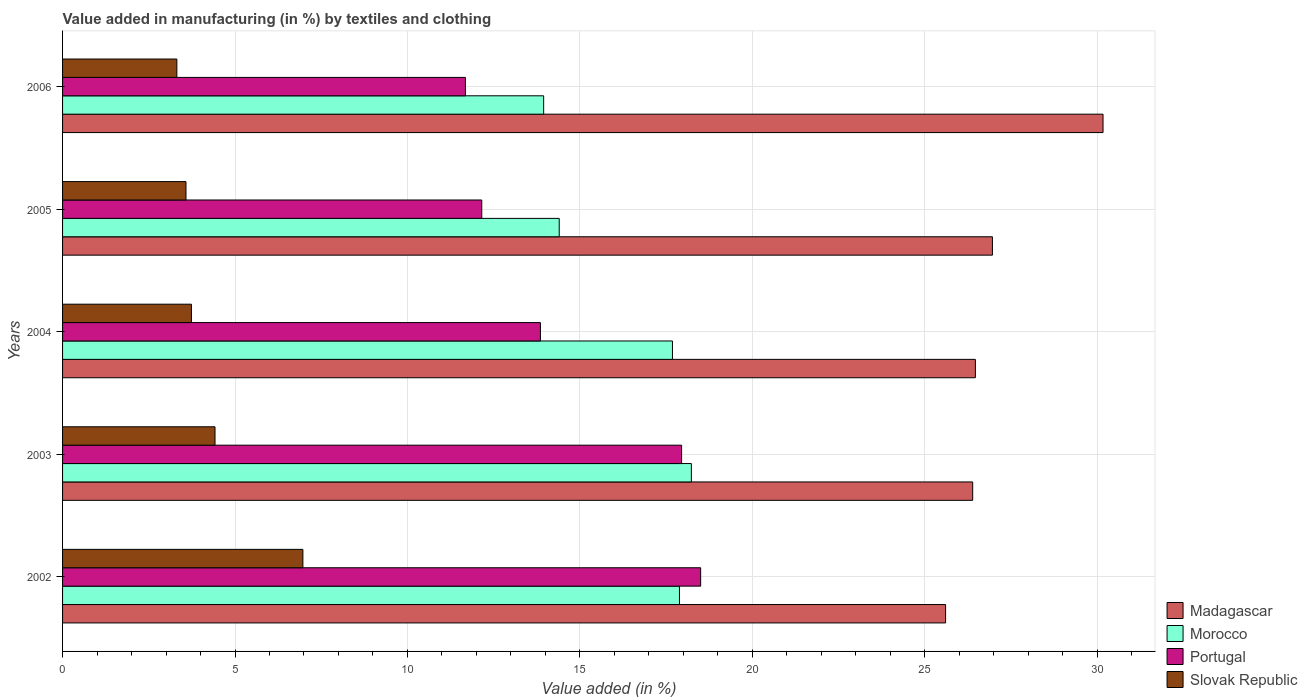How many groups of bars are there?
Provide a short and direct response. 5. Are the number of bars on each tick of the Y-axis equal?
Keep it short and to the point. Yes. How many bars are there on the 3rd tick from the top?
Your response must be concise. 4. How many bars are there on the 5th tick from the bottom?
Offer a terse response. 4. What is the label of the 2nd group of bars from the top?
Provide a short and direct response. 2005. What is the percentage of value added in manufacturing by textiles and clothing in Slovak Republic in 2003?
Make the answer very short. 4.42. Across all years, what is the maximum percentage of value added in manufacturing by textiles and clothing in Morocco?
Your answer should be very brief. 18.23. Across all years, what is the minimum percentage of value added in manufacturing by textiles and clothing in Slovak Republic?
Give a very brief answer. 3.31. In which year was the percentage of value added in manufacturing by textiles and clothing in Madagascar minimum?
Ensure brevity in your answer.  2002. What is the total percentage of value added in manufacturing by textiles and clothing in Portugal in the graph?
Offer a very short reply. 74.15. What is the difference between the percentage of value added in manufacturing by textiles and clothing in Slovak Republic in 2004 and that in 2006?
Offer a very short reply. 0.42. What is the difference between the percentage of value added in manufacturing by textiles and clothing in Morocco in 2006 and the percentage of value added in manufacturing by textiles and clothing in Portugal in 2002?
Make the answer very short. -4.55. What is the average percentage of value added in manufacturing by textiles and clothing in Slovak Republic per year?
Provide a short and direct response. 4.4. In the year 2004, what is the difference between the percentage of value added in manufacturing by textiles and clothing in Madagascar and percentage of value added in manufacturing by textiles and clothing in Morocco?
Keep it short and to the point. 8.78. What is the ratio of the percentage of value added in manufacturing by textiles and clothing in Portugal in 2004 to that in 2005?
Keep it short and to the point. 1.14. Is the difference between the percentage of value added in manufacturing by textiles and clothing in Madagascar in 2003 and 2006 greater than the difference between the percentage of value added in manufacturing by textiles and clothing in Morocco in 2003 and 2006?
Your answer should be very brief. No. What is the difference between the highest and the second highest percentage of value added in manufacturing by textiles and clothing in Portugal?
Your answer should be very brief. 0.55. What is the difference between the highest and the lowest percentage of value added in manufacturing by textiles and clothing in Morocco?
Make the answer very short. 4.28. In how many years, is the percentage of value added in manufacturing by textiles and clothing in Slovak Republic greater than the average percentage of value added in manufacturing by textiles and clothing in Slovak Republic taken over all years?
Your response must be concise. 2. What does the 1st bar from the top in 2005 represents?
Offer a terse response. Slovak Republic. What does the 3rd bar from the bottom in 2004 represents?
Your answer should be compact. Portugal. Are all the bars in the graph horizontal?
Your answer should be very brief. Yes. How many years are there in the graph?
Offer a terse response. 5. Are the values on the major ticks of X-axis written in scientific E-notation?
Provide a short and direct response. No. Does the graph contain any zero values?
Offer a terse response. No. Does the graph contain grids?
Ensure brevity in your answer.  Yes. Where does the legend appear in the graph?
Keep it short and to the point. Bottom right. How many legend labels are there?
Your answer should be compact. 4. What is the title of the graph?
Your answer should be very brief. Value added in manufacturing (in %) by textiles and clothing. What is the label or title of the X-axis?
Provide a short and direct response. Value added (in %). What is the Value added (in %) of Madagascar in 2002?
Keep it short and to the point. 25.61. What is the Value added (in %) of Morocco in 2002?
Provide a succinct answer. 17.89. What is the Value added (in %) of Portugal in 2002?
Make the answer very short. 18.5. What is the Value added (in %) in Slovak Republic in 2002?
Make the answer very short. 6.97. What is the Value added (in %) in Madagascar in 2003?
Offer a terse response. 26.39. What is the Value added (in %) in Morocco in 2003?
Your answer should be compact. 18.23. What is the Value added (in %) in Portugal in 2003?
Offer a very short reply. 17.95. What is the Value added (in %) of Slovak Republic in 2003?
Provide a short and direct response. 4.42. What is the Value added (in %) of Madagascar in 2004?
Keep it short and to the point. 26.47. What is the Value added (in %) in Morocco in 2004?
Offer a very short reply. 17.68. What is the Value added (in %) in Portugal in 2004?
Keep it short and to the point. 13.86. What is the Value added (in %) of Slovak Republic in 2004?
Your answer should be very brief. 3.74. What is the Value added (in %) in Madagascar in 2005?
Offer a very short reply. 26.96. What is the Value added (in %) of Morocco in 2005?
Make the answer very short. 14.4. What is the Value added (in %) in Portugal in 2005?
Give a very brief answer. 12.16. What is the Value added (in %) of Slovak Republic in 2005?
Provide a short and direct response. 3.58. What is the Value added (in %) of Madagascar in 2006?
Give a very brief answer. 30.17. What is the Value added (in %) of Morocco in 2006?
Keep it short and to the point. 13.95. What is the Value added (in %) in Portugal in 2006?
Provide a short and direct response. 11.68. What is the Value added (in %) of Slovak Republic in 2006?
Your answer should be compact. 3.31. Across all years, what is the maximum Value added (in %) of Madagascar?
Make the answer very short. 30.17. Across all years, what is the maximum Value added (in %) in Morocco?
Keep it short and to the point. 18.23. Across all years, what is the maximum Value added (in %) of Portugal?
Provide a short and direct response. 18.5. Across all years, what is the maximum Value added (in %) in Slovak Republic?
Give a very brief answer. 6.97. Across all years, what is the minimum Value added (in %) in Madagascar?
Your answer should be compact. 25.61. Across all years, what is the minimum Value added (in %) of Morocco?
Your answer should be very brief. 13.95. Across all years, what is the minimum Value added (in %) in Portugal?
Offer a terse response. 11.68. Across all years, what is the minimum Value added (in %) in Slovak Republic?
Keep it short and to the point. 3.31. What is the total Value added (in %) of Madagascar in the graph?
Offer a very short reply. 135.6. What is the total Value added (in %) of Morocco in the graph?
Your response must be concise. 82.16. What is the total Value added (in %) in Portugal in the graph?
Provide a short and direct response. 74.15. What is the total Value added (in %) of Slovak Republic in the graph?
Your response must be concise. 22.02. What is the difference between the Value added (in %) in Madagascar in 2002 and that in 2003?
Ensure brevity in your answer.  -0.79. What is the difference between the Value added (in %) of Morocco in 2002 and that in 2003?
Your response must be concise. -0.35. What is the difference between the Value added (in %) of Portugal in 2002 and that in 2003?
Your response must be concise. 0.55. What is the difference between the Value added (in %) in Slovak Republic in 2002 and that in 2003?
Make the answer very short. 2.55. What is the difference between the Value added (in %) of Madagascar in 2002 and that in 2004?
Give a very brief answer. -0.86. What is the difference between the Value added (in %) in Morocco in 2002 and that in 2004?
Provide a short and direct response. 0.2. What is the difference between the Value added (in %) in Portugal in 2002 and that in 2004?
Your answer should be compact. 4.65. What is the difference between the Value added (in %) in Slovak Republic in 2002 and that in 2004?
Provide a short and direct response. 3.23. What is the difference between the Value added (in %) in Madagascar in 2002 and that in 2005?
Offer a terse response. -1.36. What is the difference between the Value added (in %) of Morocco in 2002 and that in 2005?
Your response must be concise. 3.49. What is the difference between the Value added (in %) in Portugal in 2002 and that in 2005?
Provide a succinct answer. 6.35. What is the difference between the Value added (in %) in Slovak Republic in 2002 and that in 2005?
Provide a short and direct response. 3.39. What is the difference between the Value added (in %) of Madagascar in 2002 and that in 2006?
Give a very brief answer. -4.57. What is the difference between the Value added (in %) in Morocco in 2002 and that in 2006?
Your answer should be very brief. 3.94. What is the difference between the Value added (in %) of Portugal in 2002 and that in 2006?
Make the answer very short. 6.82. What is the difference between the Value added (in %) in Slovak Republic in 2002 and that in 2006?
Your response must be concise. 3.65. What is the difference between the Value added (in %) of Madagascar in 2003 and that in 2004?
Your answer should be very brief. -0.08. What is the difference between the Value added (in %) in Morocco in 2003 and that in 2004?
Your answer should be very brief. 0.55. What is the difference between the Value added (in %) of Portugal in 2003 and that in 2004?
Provide a short and direct response. 4.09. What is the difference between the Value added (in %) in Slovak Republic in 2003 and that in 2004?
Make the answer very short. 0.68. What is the difference between the Value added (in %) of Madagascar in 2003 and that in 2005?
Offer a terse response. -0.57. What is the difference between the Value added (in %) of Morocco in 2003 and that in 2005?
Provide a short and direct response. 3.83. What is the difference between the Value added (in %) in Portugal in 2003 and that in 2005?
Provide a short and direct response. 5.79. What is the difference between the Value added (in %) of Slovak Republic in 2003 and that in 2005?
Provide a short and direct response. 0.84. What is the difference between the Value added (in %) of Madagascar in 2003 and that in 2006?
Your answer should be very brief. -3.78. What is the difference between the Value added (in %) of Morocco in 2003 and that in 2006?
Provide a succinct answer. 4.28. What is the difference between the Value added (in %) in Portugal in 2003 and that in 2006?
Your answer should be compact. 6.27. What is the difference between the Value added (in %) of Slovak Republic in 2003 and that in 2006?
Offer a very short reply. 1.11. What is the difference between the Value added (in %) in Madagascar in 2004 and that in 2005?
Your answer should be compact. -0.49. What is the difference between the Value added (in %) in Morocco in 2004 and that in 2005?
Offer a terse response. 3.28. What is the difference between the Value added (in %) of Portugal in 2004 and that in 2005?
Offer a terse response. 1.7. What is the difference between the Value added (in %) in Slovak Republic in 2004 and that in 2005?
Ensure brevity in your answer.  0.16. What is the difference between the Value added (in %) of Madagascar in 2004 and that in 2006?
Make the answer very short. -3.7. What is the difference between the Value added (in %) of Morocco in 2004 and that in 2006?
Offer a very short reply. 3.73. What is the difference between the Value added (in %) of Portugal in 2004 and that in 2006?
Give a very brief answer. 2.17. What is the difference between the Value added (in %) of Slovak Republic in 2004 and that in 2006?
Your response must be concise. 0.42. What is the difference between the Value added (in %) in Madagascar in 2005 and that in 2006?
Provide a succinct answer. -3.21. What is the difference between the Value added (in %) in Morocco in 2005 and that in 2006?
Give a very brief answer. 0.45. What is the difference between the Value added (in %) of Portugal in 2005 and that in 2006?
Keep it short and to the point. 0.47. What is the difference between the Value added (in %) of Slovak Republic in 2005 and that in 2006?
Provide a short and direct response. 0.26. What is the difference between the Value added (in %) of Madagascar in 2002 and the Value added (in %) of Morocco in 2003?
Make the answer very short. 7.37. What is the difference between the Value added (in %) of Madagascar in 2002 and the Value added (in %) of Portugal in 2003?
Your response must be concise. 7.66. What is the difference between the Value added (in %) of Madagascar in 2002 and the Value added (in %) of Slovak Republic in 2003?
Provide a succinct answer. 21.18. What is the difference between the Value added (in %) in Morocco in 2002 and the Value added (in %) in Portugal in 2003?
Offer a terse response. -0.06. What is the difference between the Value added (in %) in Morocco in 2002 and the Value added (in %) in Slovak Republic in 2003?
Provide a succinct answer. 13.47. What is the difference between the Value added (in %) in Portugal in 2002 and the Value added (in %) in Slovak Republic in 2003?
Provide a succinct answer. 14.08. What is the difference between the Value added (in %) in Madagascar in 2002 and the Value added (in %) in Morocco in 2004?
Provide a succinct answer. 7.92. What is the difference between the Value added (in %) of Madagascar in 2002 and the Value added (in %) of Portugal in 2004?
Make the answer very short. 11.75. What is the difference between the Value added (in %) in Madagascar in 2002 and the Value added (in %) in Slovak Republic in 2004?
Keep it short and to the point. 21.87. What is the difference between the Value added (in %) of Morocco in 2002 and the Value added (in %) of Portugal in 2004?
Give a very brief answer. 4.03. What is the difference between the Value added (in %) in Morocco in 2002 and the Value added (in %) in Slovak Republic in 2004?
Your answer should be compact. 14.15. What is the difference between the Value added (in %) in Portugal in 2002 and the Value added (in %) in Slovak Republic in 2004?
Make the answer very short. 14.77. What is the difference between the Value added (in %) of Madagascar in 2002 and the Value added (in %) of Morocco in 2005?
Provide a succinct answer. 11.2. What is the difference between the Value added (in %) of Madagascar in 2002 and the Value added (in %) of Portugal in 2005?
Make the answer very short. 13.45. What is the difference between the Value added (in %) in Madagascar in 2002 and the Value added (in %) in Slovak Republic in 2005?
Keep it short and to the point. 22.03. What is the difference between the Value added (in %) of Morocco in 2002 and the Value added (in %) of Portugal in 2005?
Offer a very short reply. 5.73. What is the difference between the Value added (in %) in Morocco in 2002 and the Value added (in %) in Slovak Republic in 2005?
Keep it short and to the point. 14.31. What is the difference between the Value added (in %) of Portugal in 2002 and the Value added (in %) of Slovak Republic in 2005?
Provide a succinct answer. 14.92. What is the difference between the Value added (in %) in Madagascar in 2002 and the Value added (in %) in Morocco in 2006?
Make the answer very short. 11.66. What is the difference between the Value added (in %) of Madagascar in 2002 and the Value added (in %) of Portugal in 2006?
Keep it short and to the point. 13.92. What is the difference between the Value added (in %) of Madagascar in 2002 and the Value added (in %) of Slovak Republic in 2006?
Give a very brief answer. 22.29. What is the difference between the Value added (in %) of Morocco in 2002 and the Value added (in %) of Portugal in 2006?
Keep it short and to the point. 6.21. What is the difference between the Value added (in %) in Morocco in 2002 and the Value added (in %) in Slovak Republic in 2006?
Provide a succinct answer. 14.57. What is the difference between the Value added (in %) of Portugal in 2002 and the Value added (in %) of Slovak Republic in 2006?
Provide a succinct answer. 15.19. What is the difference between the Value added (in %) of Madagascar in 2003 and the Value added (in %) of Morocco in 2004?
Make the answer very short. 8.71. What is the difference between the Value added (in %) of Madagascar in 2003 and the Value added (in %) of Portugal in 2004?
Provide a short and direct response. 12.53. What is the difference between the Value added (in %) of Madagascar in 2003 and the Value added (in %) of Slovak Republic in 2004?
Your response must be concise. 22.65. What is the difference between the Value added (in %) in Morocco in 2003 and the Value added (in %) in Portugal in 2004?
Offer a very short reply. 4.38. What is the difference between the Value added (in %) of Morocco in 2003 and the Value added (in %) of Slovak Republic in 2004?
Make the answer very short. 14.5. What is the difference between the Value added (in %) in Portugal in 2003 and the Value added (in %) in Slovak Republic in 2004?
Your answer should be very brief. 14.21. What is the difference between the Value added (in %) of Madagascar in 2003 and the Value added (in %) of Morocco in 2005?
Your answer should be compact. 11.99. What is the difference between the Value added (in %) in Madagascar in 2003 and the Value added (in %) in Portugal in 2005?
Ensure brevity in your answer.  14.24. What is the difference between the Value added (in %) of Madagascar in 2003 and the Value added (in %) of Slovak Republic in 2005?
Your answer should be compact. 22.81. What is the difference between the Value added (in %) in Morocco in 2003 and the Value added (in %) in Portugal in 2005?
Offer a very short reply. 6.08. What is the difference between the Value added (in %) in Morocco in 2003 and the Value added (in %) in Slovak Republic in 2005?
Your answer should be very brief. 14.65. What is the difference between the Value added (in %) of Portugal in 2003 and the Value added (in %) of Slovak Republic in 2005?
Give a very brief answer. 14.37. What is the difference between the Value added (in %) in Madagascar in 2003 and the Value added (in %) in Morocco in 2006?
Give a very brief answer. 12.44. What is the difference between the Value added (in %) in Madagascar in 2003 and the Value added (in %) in Portugal in 2006?
Ensure brevity in your answer.  14.71. What is the difference between the Value added (in %) of Madagascar in 2003 and the Value added (in %) of Slovak Republic in 2006?
Keep it short and to the point. 23.08. What is the difference between the Value added (in %) in Morocco in 2003 and the Value added (in %) in Portugal in 2006?
Your response must be concise. 6.55. What is the difference between the Value added (in %) in Morocco in 2003 and the Value added (in %) in Slovak Republic in 2006?
Keep it short and to the point. 14.92. What is the difference between the Value added (in %) of Portugal in 2003 and the Value added (in %) of Slovak Republic in 2006?
Make the answer very short. 14.64. What is the difference between the Value added (in %) of Madagascar in 2004 and the Value added (in %) of Morocco in 2005?
Your answer should be compact. 12.07. What is the difference between the Value added (in %) in Madagascar in 2004 and the Value added (in %) in Portugal in 2005?
Your answer should be compact. 14.31. What is the difference between the Value added (in %) of Madagascar in 2004 and the Value added (in %) of Slovak Republic in 2005?
Offer a very short reply. 22.89. What is the difference between the Value added (in %) in Morocco in 2004 and the Value added (in %) in Portugal in 2005?
Your response must be concise. 5.53. What is the difference between the Value added (in %) of Morocco in 2004 and the Value added (in %) of Slovak Republic in 2005?
Provide a succinct answer. 14.11. What is the difference between the Value added (in %) of Portugal in 2004 and the Value added (in %) of Slovak Republic in 2005?
Offer a terse response. 10.28. What is the difference between the Value added (in %) in Madagascar in 2004 and the Value added (in %) in Morocco in 2006?
Your answer should be very brief. 12.52. What is the difference between the Value added (in %) in Madagascar in 2004 and the Value added (in %) in Portugal in 2006?
Make the answer very short. 14.79. What is the difference between the Value added (in %) in Madagascar in 2004 and the Value added (in %) in Slovak Republic in 2006?
Your response must be concise. 23.15. What is the difference between the Value added (in %) in Morocco in 2004 and the Value added (in %) in Portugal in 2006?
Offer a very short reply. 6. What is the difference between the Value added (in %) in Morocco in 2004 and the Value added (in %) in Slovak Republic in 2006?
Give a very brief answer. 14.37. What is the difference between the Value added (in %) of Portugal in 2004 and the Value added (in %) of Slovak Republic in 2006?
Ensure brevity in your answer.  10.54. What is the difference between the Value added (in %) of Madagascar in 2005 and the Value added (in %) of Morocco in 2006?
Provide a short and direct response. 13.01. What is the difference between the Value added (in %) of Madagascar in 2005 and the Value added (in %) of Portugal in 2006?
Keep it short and to the point. 15.28. What is the difference between the Value added (in %) in Madagascar in 2005 and the Value added (in %) in Slovak Republic in 2006?
Give a very brief answer. 23.65. What is the difference between the Value added (in %) of Morocco in 2005 and the Value added (in %) of Portugal in 2006?
Offer a very short reply. 2.72. What is the difference between the Value added (in %) of Morocco in 2005 and the Value added (in %) of Slovak Republic in 2006?
Provide a short and direct response. 11.09. What is the difference between the Value added (in %) of Portugal in 2005 and the Value added (in %) of Slovak Republic in 2006?
Provide a short and direct response. 8.84. What is the average Value added (in %) in Madagascar per year?
Give a very brief answer. 27.12. What is the average Value added (in %) in Morocco per year?
Give a very brief answer. 16.43. What is the average Value added (in %) in Portugal per year?
Give a very brief answer. 14.83. What is the average Value added (in %) in Slovak Republic per year?
Offer a terse response. 4.4. In the year 2002, what is the difference between the Value added (in %) in Madagascar and Value added (in %) in Morocco?
Offer a very short reply. 7.72. In the year 2002, what is the difference between the Value added (in %) in Madagascar and Value added (in %) in Portugal?
Make the answer very short. 7.1. In the year 2002, what is the difference between the Value added (in %) in Madagascar and Value added (in %) in Slovak Republic?
Give a very brief answer. 18.64. In the year 2002, what is the difference between the Value added (in %) in Morocco and Value added (in %) in Portugal?
Your answer should be compact. -0.61. In the year 2002, what is the difference between the Value added (in %) in Morocco and Value added (in %) in Slovak Republic?
Your answer should be compact. 10.92. In the year 2002, what is the difference between the Value added (in %) of Portugal and Value added (in %) of Slovak Republic?
Provide a succinct answer. 11.53. In the year 2003, what is the difference between the Value added (in %) in Madagascar and Value added (in %) in Morocco?
Your answer should be very brief. 8.16. In the year 2003, what is the difference between the Value added (in %) of Madagascar and Value added (in %) of Portugal?
Provide a succinct answer. 8.44. In the year 2003, what is the difference between the Value added (in %) in Madagascar and Value added (in %) in Slovak Republic?
Provide a short and direct response. 21.97. In the year 2003, what is the difference between the Value added (in %) in Morocco and Value added (in %) in Portugal?
Provide a succinct answer. 0.28. In the year 2003, what is the difference between the Value added (in %) of Morocco and Value added (in %) of Slovak Republic?
Keep it short and to the point. 13.81. In the year 2003, what is the difference between the Value added (in %) in Portugal and Value added (in %) in Slovak Republic?
Provide a short and direct response. 13.53. In the year 2004, what is the difference between the Value added (in %) of Madagascar and Value added (in %) of Morocco?
Ensure brevity in your answer.  8.78. In the year 2004, what is the difference between the Value added (in %) in Madagascar and Value added (in %) in Portugal?
Offer a very short reply. 12.61. In the year 2004, what is the difference between the Value added (in %) in Madagascar and Value added (in %) in Slovak Republic?
Keep it short and to the point. 22.73. In the year 2004, what is the difference between the Value added (in %) in Morocco and Value added (in %) in Portugal?
Provide a succinct answer. 3.83. In the year 2004, what is the difference between the Value added (in %) of Morocco and Value added (in %) of Slovak Republic?
Keep it short and to the point. 13.95. In the year 2004, what is the difference between the Value added (in %) in Portugal and Value added (in %) in Slovak Republic?
Your answer should be very brief. 10.12. In the year 2005, what is the difference between the Value added (in %) in Madagascar and Value added (in %) in Morocco?
Your answer should be compact. 12.56. In the year 2005, what is the difference between the Value added (in %) of Madagascar and Value added (in %) of Portugal?
Your response must be concise. 14.81. In the year 2005, what is the difference between the Value added (in %) of Madagascar and Value added (in %) of Slovak Republic?
Offer a very short reply. 23.38. In the year 2005, what is the difference between the Value added (in %) of Morocco and Value added (in %) of Portugal?
Your answer should be compact. 2.25. In the year 2005, what is the difference between the Value added (in %) in Morocco and Value added (in %) in Slovak Republic?
Keep it short and to the point. 10.82. In the year 2005, what is the difference between the Value added (in %) in Portugal and Value added (in %) in Slovak Republic?
Provide a short and direct response. 8.58. In the year 2006, what is the difference between the Value added (in %) in Madagascar and Value added (in %) in Morocco?
Give a very brief answer. 16.22. In the year 2006, what is the difference between the Value added (in %) in Madagascar and Value added (in %) in Portugal?
Your response must be concise. 18.49. In the year 2006, what is the difference between the Value added (in %) in Madagascar and Value added (in %) in Slovak Republic?
Provide a succinct answer. 26.86. In the year 2006, what is the difference between the Value added (in %) in Morocco and Value added (in %) in Portugal?
Offer a very short reply. 2.27. In the year 2006, what is the difference between the Value added (in %) in Morocco and Value added (in %) in Slovak Republic?
Make the answer very short. 10.64. In the year 2006, what is the difference between the Value added (in %) of Portugal and Value added (in %) of Slovak Republic?
Keep it short and to the point. 8.37. What is the ratio of the Value added (in %) in Madagascar in 2002 to that in 2003?
Keep it short and to the point. 0.97. What is the ratio of the Value added (in %) of Morocco in 2002 to that in 2003?
Provide a succinct answer. 0.98. What is the ratio of the Value added (in %) of Portugal in 2002 to that in 2003?
Ensure brevity in your answer.  1.03. What is the ratio of the Value added (in %) of Slovak Republic in 2002 to that in 2003?
Your answer should be very brief. 1.58. What is the ratio of the Value added (in %) of Madagascar in 2002 to that in 2004?
Offer a very short reply. 0.97. What is the ratio of the Value added (in %) of Morocco in 2002 to that in 2004?
Offer a very short reply. 1.01. What is the ratio of the Value added (in %) of Portugal in 2002 to that in 2004?
Ensure brevity in your answer.  1.34. What is the ratio of the Value added (in %) in Slovak Republic in 2002 to that in 2004?
Your answer should be very brief. 1.87. What is the ratio of the Value added (in %) of Madagascar in 2002 to that in 2005?
Your answer should be very brief. 0.95. What is the ratio of the Value added (in %) of Morocco in 2002 to that in 2005?
Your answer should be compact. 1.24. What is the ratio of the Value added (in %) of Portugal in 2002 to that in 2005?
Make the answer very short. 1.52. What is the ratio of the Value added (in %) in Slovak Republic in 2002 to that in 2005?
Provide a short and direct response. 1.95. What is the ratio of the Value added (in %) of Madagascar in 2002 to that in 2006?
Your response must be concise. 0.85. What is the ratio of the Value added (in %) of Morocco in 2002 to that in 2006?
Ensure brevity in your answer.  1.28. What is the ratio of the Value added (in %) in Portugal in 2002 to that in 2006?
Your answer should be compact. 1.58. What is the ratio of the Value added (in %) in Slovak Republic in 2002 to that in 2006?
Offer a terse response. 2.1. What is the ratio of the Value added (in %) in Madagascar in 2003 to that in 2004?
Provide a short and direct response. 1. What is the ratio of the Value added (in %) of Morocco in 2003 to that in 2004?
Offer a terse response. 1.03. What is the ratio of the Value added (in %) of Portugal in 2003 to that in 2004?
Provide a short and direct response. 1.3. What is the ratio of the Value added (in %) in Slovak Republic in 2003 to that in 2004?
Keep it short and to the point. 1.18. What is the ratio of the Value added (in %) of Madagascar in 2003 to that in 2005?
Your answer should be very brief. 0.98. What is the ratio of the Value added (in %) in Morocco in 2003 to that in 2005?
Your response must be concise. 1.27. What is the ratio of the Value added (in %) in Portugal in 2003 to that in 2005?
Your answer should be compact. 1.48. What is the ratio of the Value added (in %) of Slovak Republic in 2003 to that in 2005?
Provide a succinct answer. 1.24. What is the ratio of the Value added (in %) in Madagascar in 2003 to that in 2006?
Your answer should be very brief. 0.87. What is the ratio of the Value added (in %) in Morocco in 2003 to that in 2006?
Your answer should be compact. 1.31. What is the ratio of the Value added (in %) of Portugal in 2003 to that in 2006?
Your answer should be compact. 1.54. What is the ratio of the Value added (in %) in Slovak Republic in 2003 to that in 2006?
Your response must be concise. 1.33. What is the ratio of the Value added (in %) in Madagascar in 2004 to that in 2005?
Make the answer very short. 0.98. What is the ratio of the Value added (in %) in Morocco in 2004 to that in 2005?
Your answer should be compact. 1.23. What is the ratio of the Value added (in %) of Portugal in 2004 to that in 2005?
Offer a very short reply. 1.14. What is the ratio of the Value added (in %) in Slovak Republic in 2004 to that in 2005?
Ensure brevity in your answer.  1.04. What is the ratio of the Value added (in %) in Madagascar in 2004 to that in 2006?
Your response must be concise. 0.88. What is the ratio of the Value added (in %) in Morocco in 2004 to that in 2006?
Your answer should be compact. 1.27. What is the ratio of the Value added (in %) in Portugal in 2004 to that in 2006?
Offer a terse response. 1.19. What is the ratio of the Value added (in %) in Slovak Republic in 2004 to that in 2006?
Make the answer very short. 1.13. What is the ratio of the Value added (in %) of Madagascar in 2005 to that in 2006?
Give a very brief answer. 0.89. What is the ratio of the Value added (in %) in Morocco in 2005 to that in 2006?
Offer a terse response. 1.03. What is the ratio of the Value added (in %) in Portugal in 2005 to that in 2006?
Give a very brief answer. 1.04. What is the ratio of the Value added (in %) of Slovak Republic in 2005 to that in 2006?
Keep it short and to the point. 1.08. What is the difference between the highest and the second highest Value added (in %) of Madagascar?
Your answer should be very brief. 3.21. What is the difference between the highest and the second highest Value added (in %) of Morocco?
Offer a terse response. 0.35. What is the difference between the highest and the second highest Value added (in %) in Portugal?
Make the answer very short. 0.55. What is the difference between the highest and the second highest Value added (in %) of Slovak Republic?
Provide a succinct answer. 2.55. What is the difference between the highest and the lowest Value added (in %) of Madagascar?
Ensure brevity in your answer.  4.57. What is the difference between the highest and the lowest Value added (in %) of Morocco?
Ensure brevity in your answer.  4.28. What is the difference between the highest and the lowest Value added (in %) of Portugal?
Offer a terse response. 6.82. What is the difference between the highest and the lowest Value added (in %) in Slovak Republic?
Offer a terse response. 3.65. 